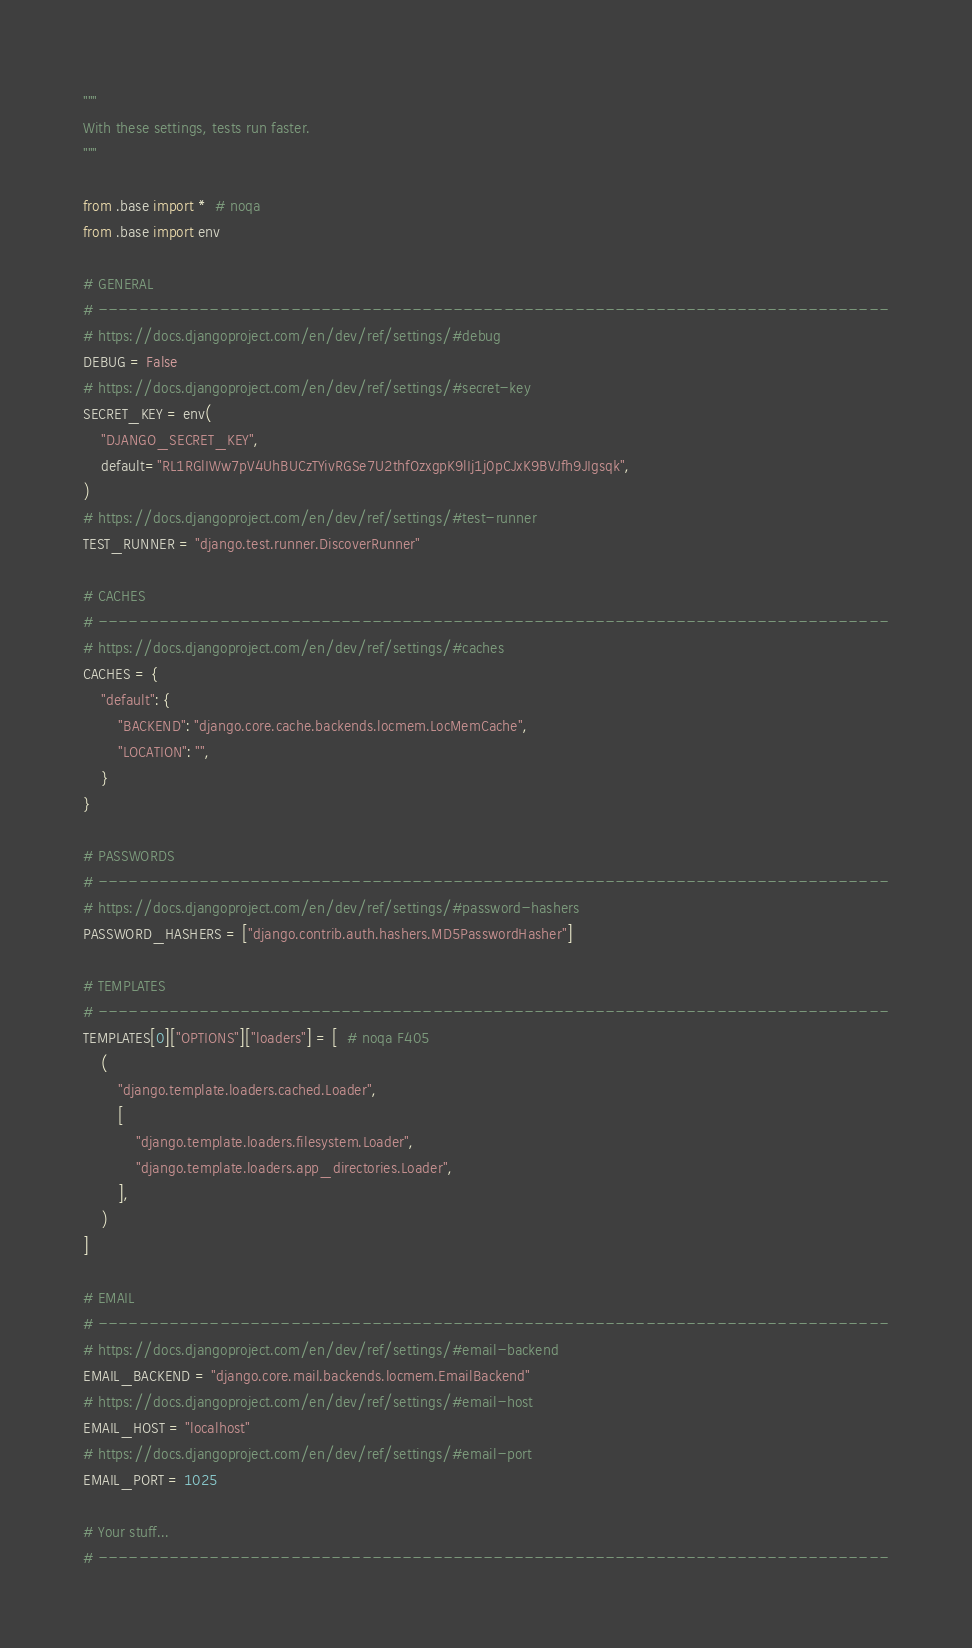Convert code to text. <code><loc_0><loc_0><loc_500><loc_500><_Python_>"""
With these settings, tests run faster.
"""

from .base import *  # noqa
from .base import env

# GENERAL
# ------------------------------------------------------------------------------
# https://docs.djangoproject.com/en/dev/ref/settings/#debug
DEBUG = False
# https://docs.djangoproject.com/en/dev/ref/settings/#secret-key
SECRET_KEY = env(
    "DJANGO_SECRET_KEY",
    default="RL1RGlIWw7pV4UhBUCzTYivRGSe7U2thfOzxgpK9lIj1j0pCJxK9BVJfh9JIgsqk",
)
# https://docs.djangoproject.com/en/dev/ref/settings/#test-runner
TEST_RUNNER = "django.test.runner.DiscoverRunner"

# CACHES
# ------------------------------------------------------------------------------
# https://docs.djangoproject.com/en/dev/ref/settings/#caches
CACHES = {
    "default": {
        "BACKEND": "django.core.cache.backends.locmem.LocMemCache",
        "LOCATION": "",
    }
}

# PASSWORDS
# ------------------------------------------------------------------------------
# https://docs.djangoproject.com/en/dev/ref/settings/#password-hashers
PASSWORD_HASHERS = ["django.contrib.auth.hashers.MD5PasswordHasher"]

# TEMPLATES
# ------------------------------------------------------------------------------
TEMPLATES[0]["OPTIONS"]["loaders"] = [  # noqa F405
    (
        "django.template.loaders.cached.Loader",
        [
            "django.template.loaders.filesystem.Loader",
            "django.template.loaders.app_directories.Loader",
        ],
    )
]

# EMAIL
# ------------------------------------------------------------------------------
# https://docs.djangoproject.com/en/dev/ref/settings/#email-backend
EMAIL_BACKEND = "django.core.mail.backends.locmem.EmailBackend"
# https://docs.djangoproject.com/en/dev/ref/settings/#email-host
EMAIL_HOST = "localhost"
# https://docs.djangoproject.com/en/dev/ref/settings/#email-port
EMAIL_PORT = 1025

# Your stuff...
# ------------------------------------------------------------------------------
</code> 